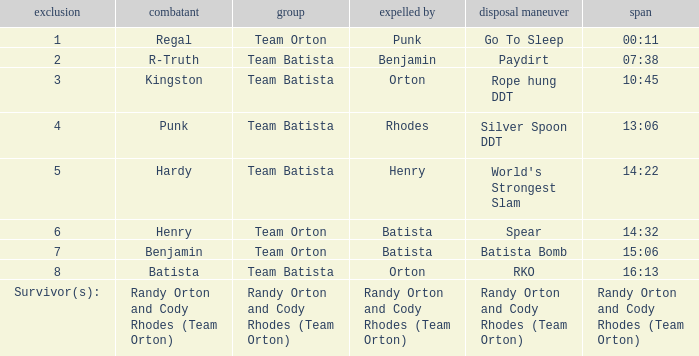What Elimination Move is listed against Wrestler Henry, Eliminated by Batista? Spear. 